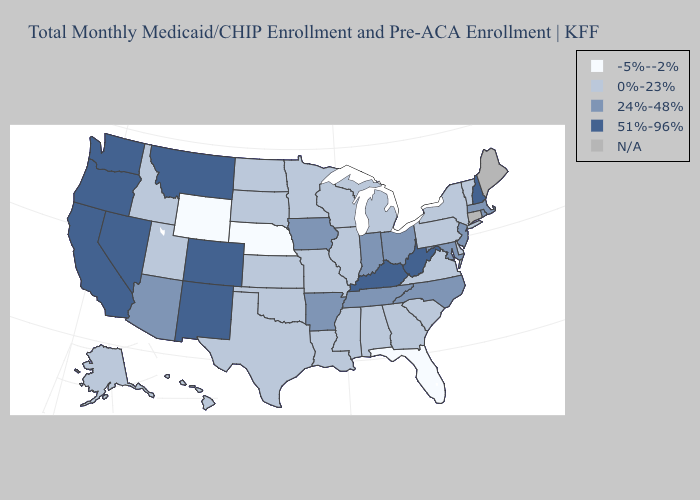Name the states that have a value in the range 51%-96%?
Answer briefly. California, Colorado, Kentucky, Montana, Nevada, New Hampshire, New Mexico, Oregon, Washington, West Virginia. Name the states that have a value in the range N/A?
Be succinct. Connecticut, Maine. What is the value of Nevada?
Be succinct. 51%-96%. What is the highest value in states that border Oklahoma?
Write a very short answer. 51%-96%. What is the value of Delaware?
Give a very brief answer. 0%-23%. Name the states that have a value in the range 24%-48%?
Give a very brief answer. Arizona, Arkansas, Indiana, Iowa, Maryland, Massachusetts, New Jersey, North Carolina, Ohio, Rhode Island, Tennessee. Name the states that have a value in the range 24%-48%?
Be succinct. Arizona, Arkansas, Indiana, Iowa, Maryland, Massachusetts, New Jersey, North Carolina, Ohio, Rhode Island, Tennessee. Name the states that have a value in the range 0%-23%?
Keep it brief. Alabama, Alaska, Delaware, Georgia, Hawaii, Idaho, Illinois, Kansas, Louisiana, Michigan, Minnesota, Mississippi, Missouri, New York, North Dakota, Oklahoma, Pennsylvania, South Carolina, South Dakota, Texas, Utah, Vermont, Virginia, Wisconsin. What is the highest value in the USA?
Keep it brief. 51%-96%. What is the value of Idaho?
Short answer required. 0%-23%. What is the value of Wisconsin?
Write a very short answer. 0%-23%. Which states have the lowest value in the USA?
Write a very short answer. Florida, Nebraska, Wyoming. Name the states that have a value in the range 24%-48%?
Short answer required. Arizona, Arkansas, Indiana, Iowa, Maryland, Massachusetts, New Jersey, North Carolina, Ohio, Rhode Island, Tennessee. Name the states that have a value in the range 0%-23%?
Short answer required. Alabama, Alaska, Delaware, Georgia, Hawaii, Idaho, Illinois, Kansas, Louisiana, Michigan, Minnesota, Mississippi, Missouri, New York, North Dakota, Oklahoma, Pennsylvania, South Carolina, South Dakota, Texas, Utah, Vermont, Virginia, Wisconsin. 